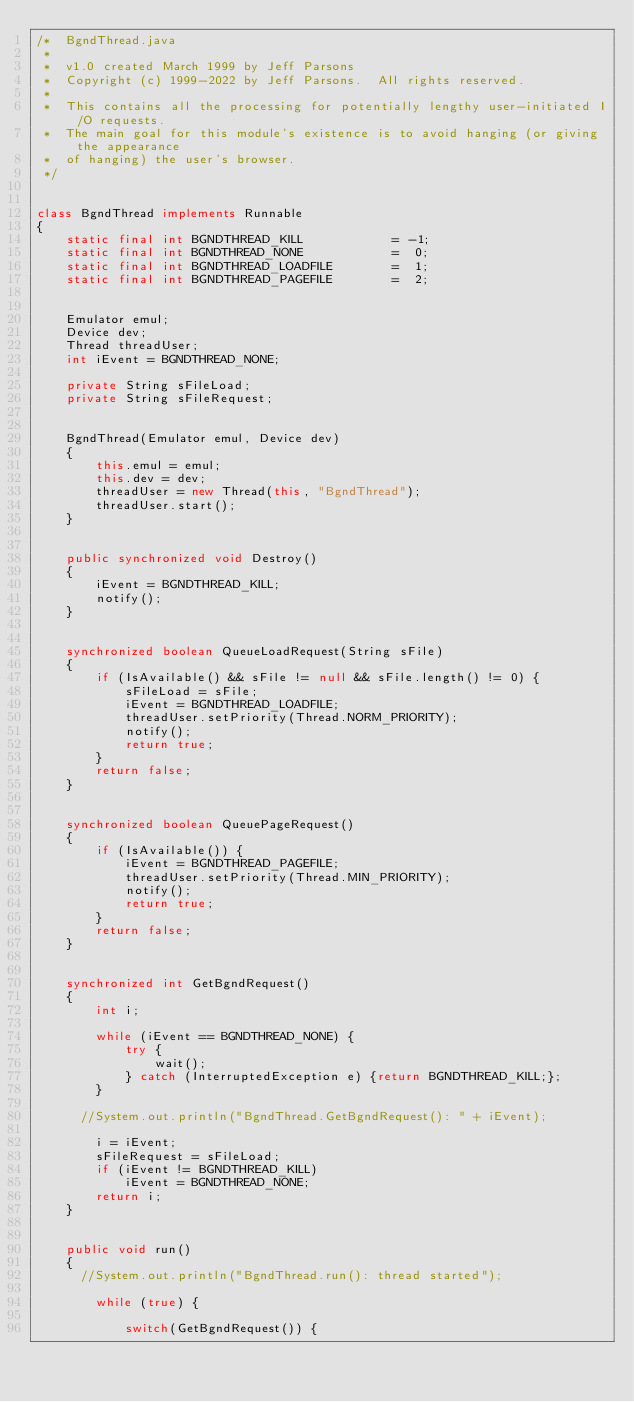<code> <loc_0><loc_0><loc_500><loc_500><_Java_>/*  BgndThread.java
 *
 *  v1.0 created March 1999 by Jeff Parsons
 *  Copyright (c) 1999-2022 by Jeff Parsons.  All rights reserved.
 *
 *  This contains all the processing for potentially lengthy user-initiated I/O requests.
 *  The main goal for this module's existence is to avoid hanging (or giving the appearance
 *  of hanging) the user's browser. 
 */


class BgndThread implements Runnable
{
    static final int BGNDTHREAD_KILL            = -1;
    static final int BGNDTHREAD_NONE            =  0;
    static final int BGNDTHREAD_LOADFILE        =  1;
    static final int BGNDTHREAD_PAGEFILE        =  2;

    
    Emulator emul;
    Device dev;
    Thread threadUser;
    int iEvent = BGNDTHREAD_NONE;

    private String sFileLoad;
    private String sFileRequest;
    

    BgndThread(Emulator emul, Device dev)
    {
        this.emul = emul;
        this.dev = dev;
        threadUser = new Thread(this, "BgndThread");
        threadUser.start();
    }
    

    public synchronized void Destroy()
    {
        iEvent = BGNDTHREAD_KILL;
        notify();
    }
    

    synchronized boolean QueueLoadRequest(String sFile)
    {
        if (IsAvailable() && sFile != null && sFile.length() != 0) {
            sFileLoad = sFile;
            iEvent = BGNDTHREAD_LOADFILE;
            threadUser.setPriority(Thread.NORM_PRIORITY);
            notify();
            return true;
        }
        return false;
    }

    
    synchronized boolean QueuePageRequest()
    {
        if (IsAvailable()) {
            iEvent = BGNDTHREAD_PAGEFILE;
            threadUser.setPriority(Thread.MIN_PRIORITY);
            notify();
            return true;
        }
        return false;
    }
    
    
    synchronized int GetBgndRequest()
    {
        int i;
        
        while (iEvent == BGNDTHREAD_NONE) {
            try {
                wait();
            } catch (InterruptedException e) {return BGNDTHREAD_KILL;};
        }
        
      //System.out.println("BgndThread.GetBgndRequest(): " + iEvent);
        
        i = iEvent;
        sFileRequest = sFileLoad;
        if (iEvent != BGNDTHREAD_KILL)
            iEvent = BGNDTHREAD_NONE;
        return i;
    }

    
    public void run()
    {
      //System.out.println("BgndThread.run(): thread started");
        
        while (true) {

            switch(GetBgndRequest()) {
                </code> 